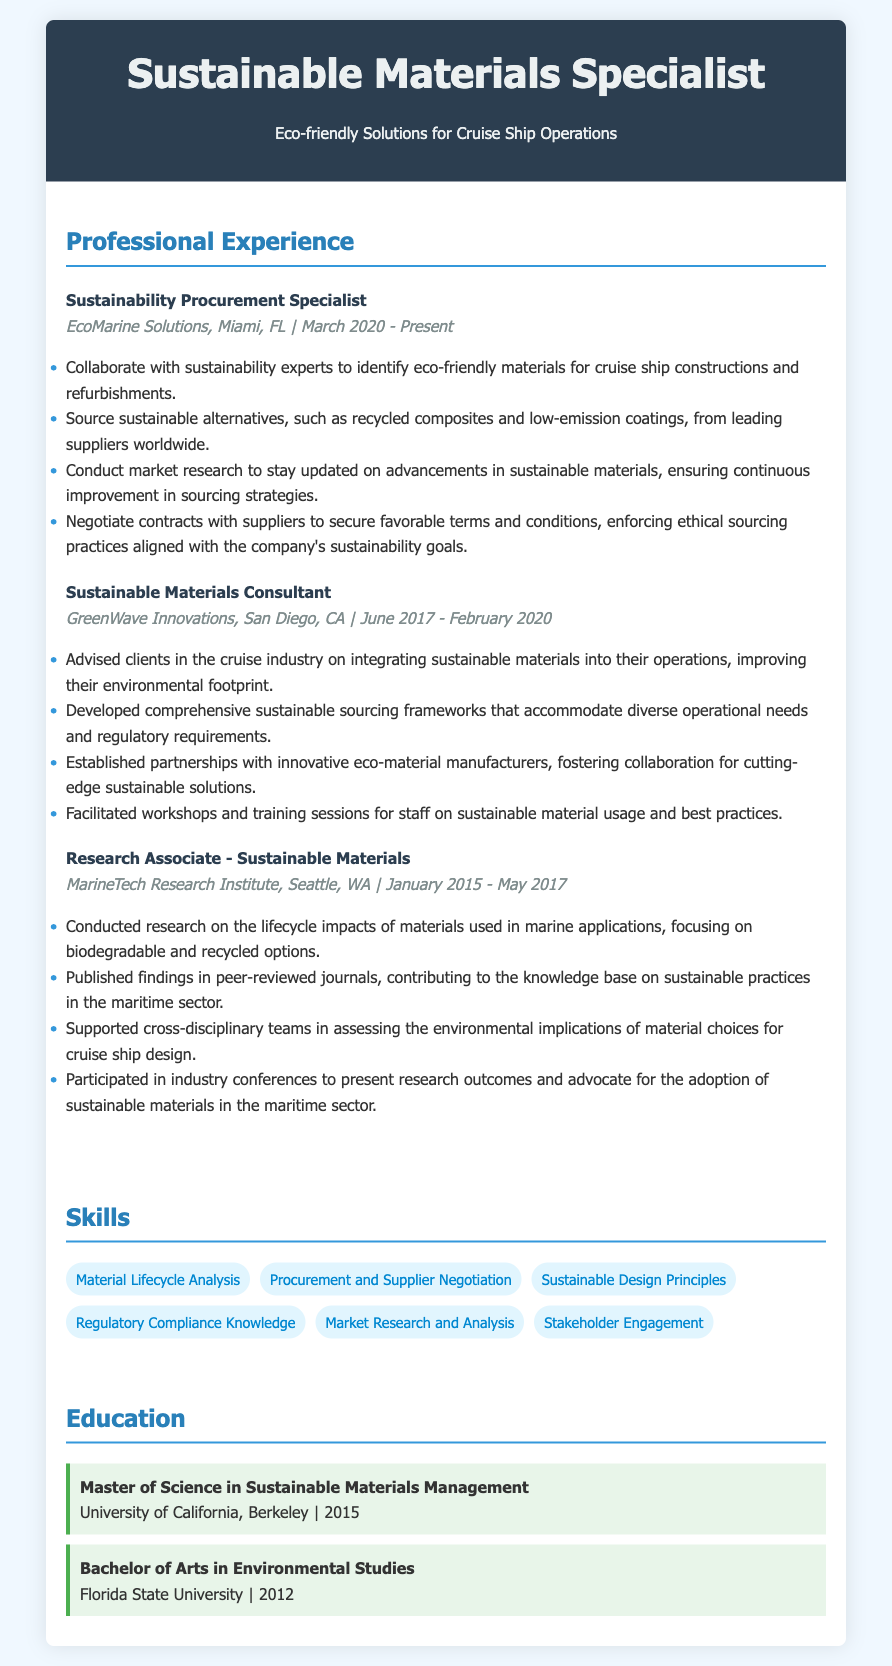What is the current position held by the candidate? The document lists the candidate's current role as Sustainability Procurement Specialist at EcoMarine Solutions.
Answer: Sustainability Procurement Specialist What company did the candidate work for in San Diego? The document specifies that the candidate worked for GreenWave Innovations in San Diego.
Answer: GreenWave Innovations In which year did the candidate complete their Master's degree? The education section states that the candidate obtained their Master's degree in 2015 from the University of California, Berkeley.
Answer: 2015 How long did the candidate work as a Sustainable Materials Consultant? The duration of the candidate's role at GreenWave Innovations is from June 2017 to February 2020, totaling approximately 2 years and 8 months.
Answer: Approximately 2 years and 8 months What type of materials did the candidate focus on at MarineTech Research Institute? The job details mention the candidate's focus on biodegradable and recycled options in marine applications.
Answer: Biodegradable and recycled options Which skill involves assessing supplier relationships? The candidate has a skill listed as Procurement and Supplier Negotiation, which involves dealing with supplier relationships.
Answer: Procurement and Supplier Negotiation What is one responsibility mentioned for the Sustainability Procurement Specialist? The document outlines that one responsibility is collaborating with sustainability experts to identify eco-friendly materials.
Answer: Collaborate with sustainability experts How many companies has the candidate worked for according to this CV? The candidate has worked for three different companies mentioned in the Professional Experience section.
Answer: Three What is the title of the first job listed in Professional Experience? The first job title in the Professional Experience section is Sustainability Procurement Specialist.
Answer: Sustainability Procurement Specialist What type of workshops did the candidate facilitate at GreenWave Innovations? The document states that the candidate facilitated workshops and training sessions for staff on sustainable material usage.
Answer: Workshops and training sessions on sustainable material usage 